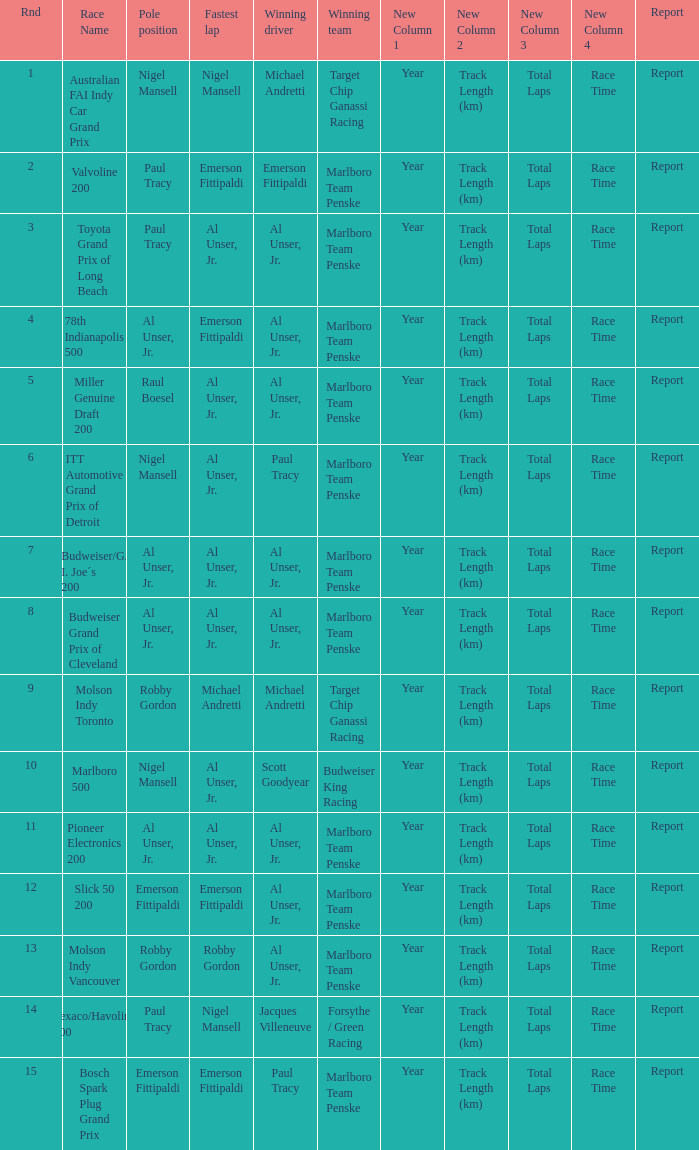Who did the fastest lap in the race won by Paul Tracy, with Emerson Fittipaldi at the pole position? Emerson Fittipaldi. 